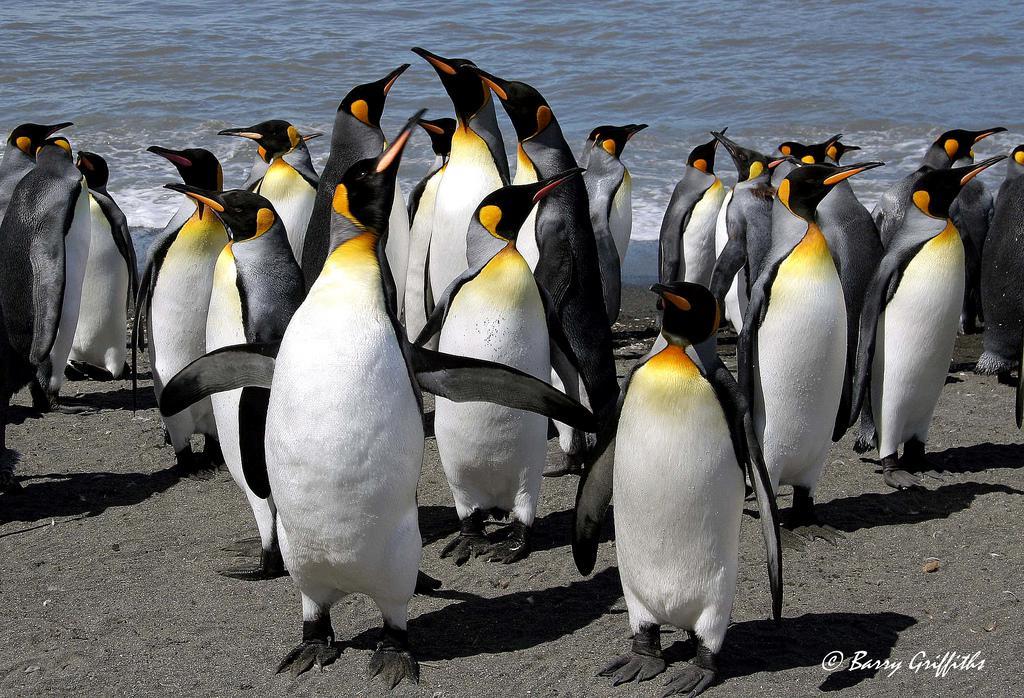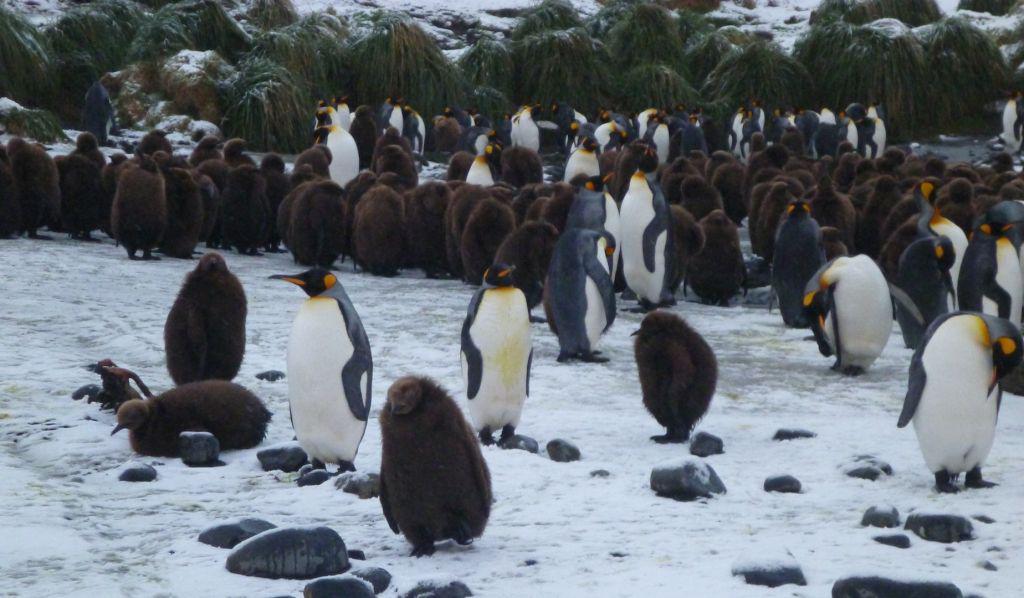The first image is the image on the left, the second image is the image on the right. Examine the images to the left and right. Is the description "Penguins are the only living creatures in the images." accurate? Answer yes or no. Yes. The first image is the image on the left, the second image is the image on the right. Given the left and right images, does the statement "One of the images shows at least one brown fluffy penguin near the black and white penguins." hold true? Answer yes or no. Yes. 